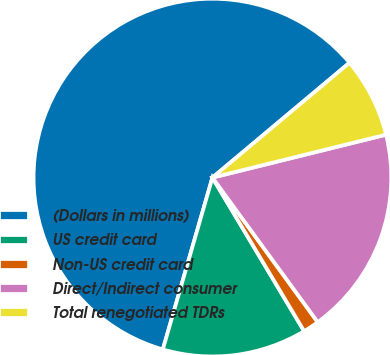Convert chart to OTSL. <chart><loc_0><loc_0><loc_500><loc_500><pie_chart><fcel>(Dollars in millions)<fcel>US credit card<fcel>Non-US credit card<fcel>Direct/Indirect consumer<fcel>Total renegotiated TDRs<nl><fcel>59.43%<fcel>13.04%<fcel>1.45%<fcel>18.84%<fcel>7.24%<nl></chart> 